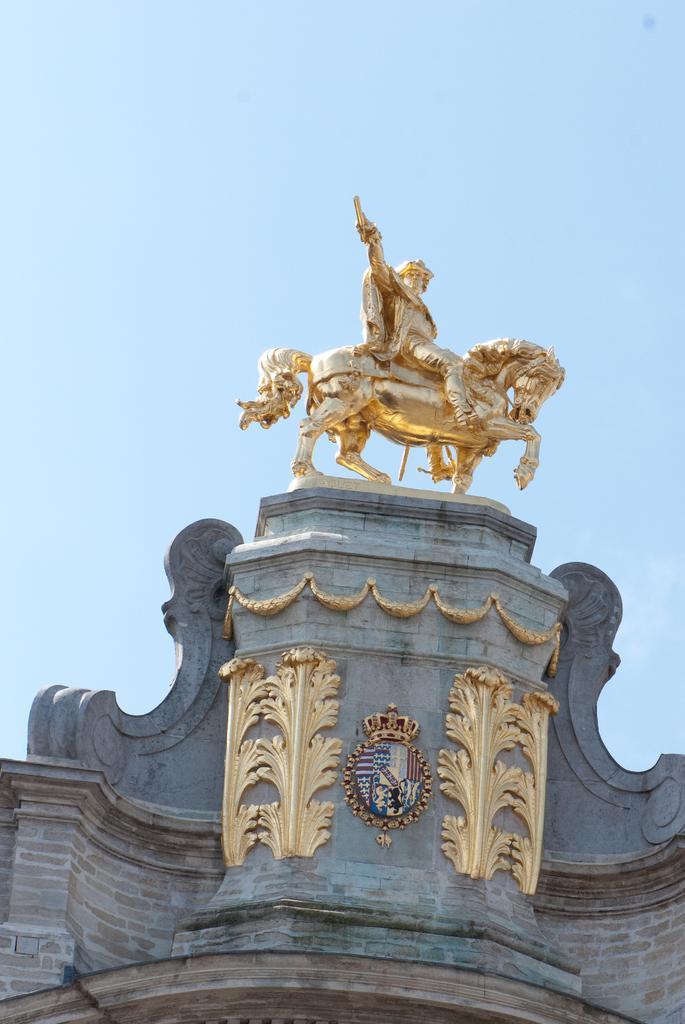In one or two sentences, can you explain what this image depicts? In this image I see the wall over here and I see the golden color sculpture over here and in the background I see the sky. 